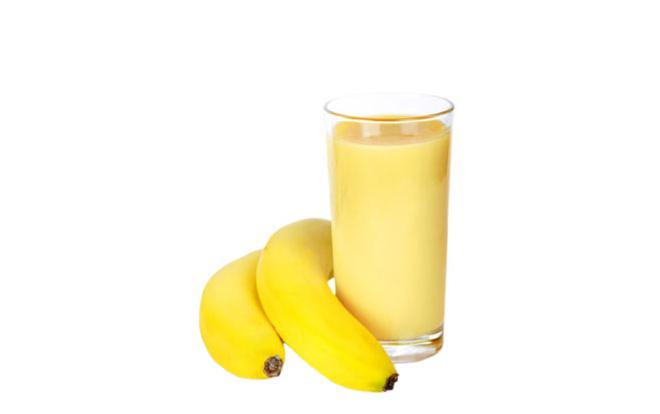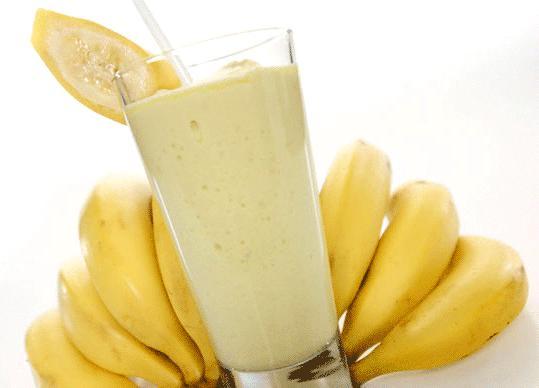The first image is the image on the left, the second image is the image on the right. For the images displayed, is the sentence "One of the images has a fruit besides just a banana." factually correct? Answer yes or no. No. 